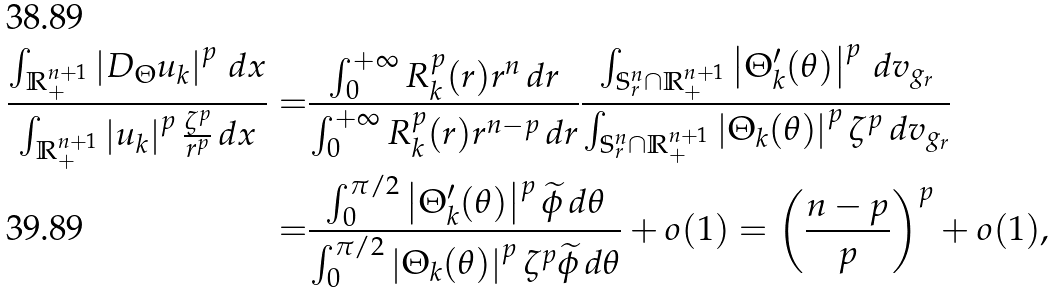<formula> <loc_0><loc_0><loc_500><loc_500>\frac { \int _ { \mathbb { R } _ { + } ^ { n + 1 } } \left | D _ { \Theta } u _ { k } \right | ^ { p } \, d x } { \int _ { \mathbb { R } _ { + } ^ { n + 1 } } \left | u _ { k } \right | ^ { p } \frac { \zeta ^ { p } } { r ^ { p } } \, d x } = & \frac { \int _ { 0 } ^ { + \infty } R _ { k } ^ { p } ( r ) r ^ { n } \, d r } { \int _ { 0 } ^ { + \infty } R _ { k } ^ { p } ( r ) r ^ { n - p } \, d r } \frac { \int _ { \mathbb { S } ^ { n } _ { r } \cap \mathbb { R } _ { + } ^ { n + 1 } } \left | \Theta _ { k } ^ { \prime } ( \theta ) \right | ^ { p } \, d v _ { g _ { r } } } { \int _ { \mathbb { S } ^ { n } _ { r } \cap \mathbb { R } _ { + } ^ { n + 1 } } \left | \Theta _ { k } ( \theta ) \right | ^ { p } \zeta ^ { p } \, d v _ { g _ { r } } } \\ = & \frac { \int _ { 0 } ^ { \pi / 2 } \left | \Theta _ { k } ^ { \prime } ( \theta ) \right | ^ { p } \widetilde { \phi } \, d \theta } { \int _ { 0 } ^ { \pi / 2 } \left | \Theta _ { k } ( \theta ) \right | ^ { p } \zeta ^ { p } \widetilde { \phi } \, d \theta } + o ( 1 ) = \left ( \frac { n - p } { p } \right ) ^ { p } + o ( 1 ) ,</formula> 